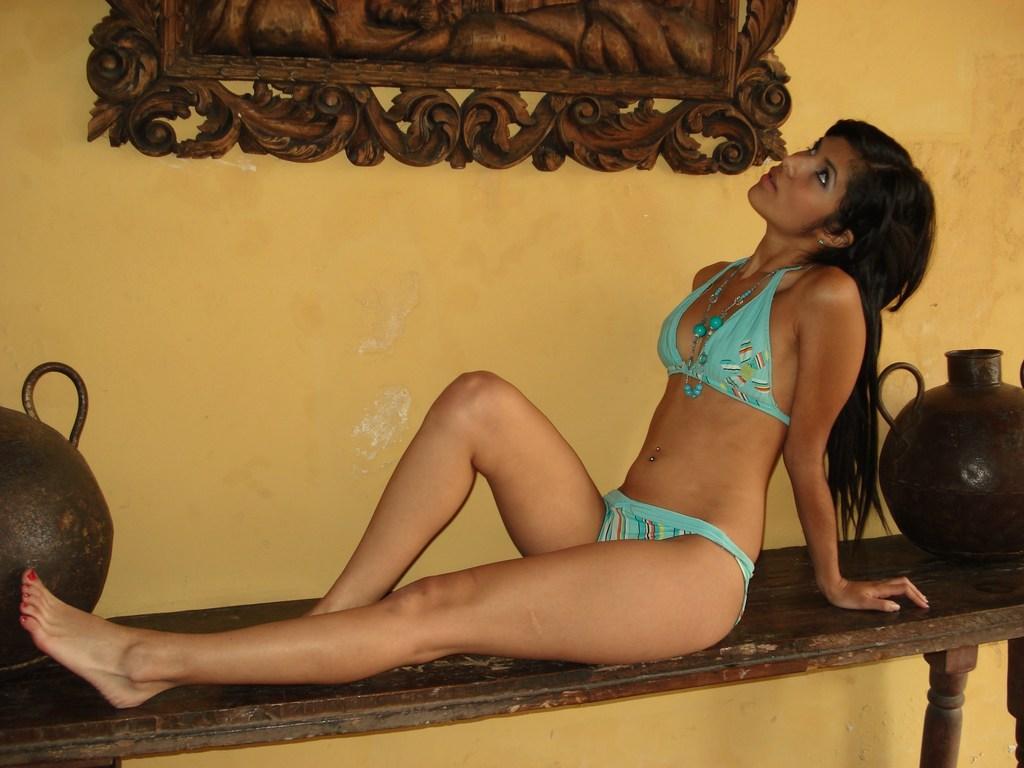Describe this image in one or two sentences. In this image I can see a person sitting on the bench. The person is wearing green dress and the bench is in brown color. Background I can see a frame attached to the wall and the wall is in yellow color. 